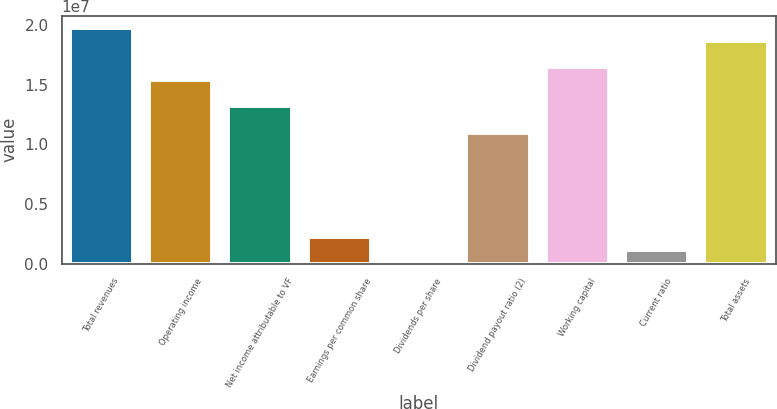<chart> <loc_0><loc_0><loc_500><loc_500><bar_chart><fcel>Total revenues<fcel>Operating income<fcel>Net income attributable to VF<fcel>Earnings per common share<fcel>Dividends per share<fcel>Dividend payout ratio (2)<fcel>Working capital<fcel>Current ratio<fcel>Total assets<nl><fcel>1.98083e+07<fcel>1.54064e+07<fcel>1.32055e+07<fcel>2.20092e+06<fcel>0.92<fcel>1.10046e+07<fcel>1.65069e+07<fcel>1.10046e+06<fcel>1.87078e+07<nl></chart> 